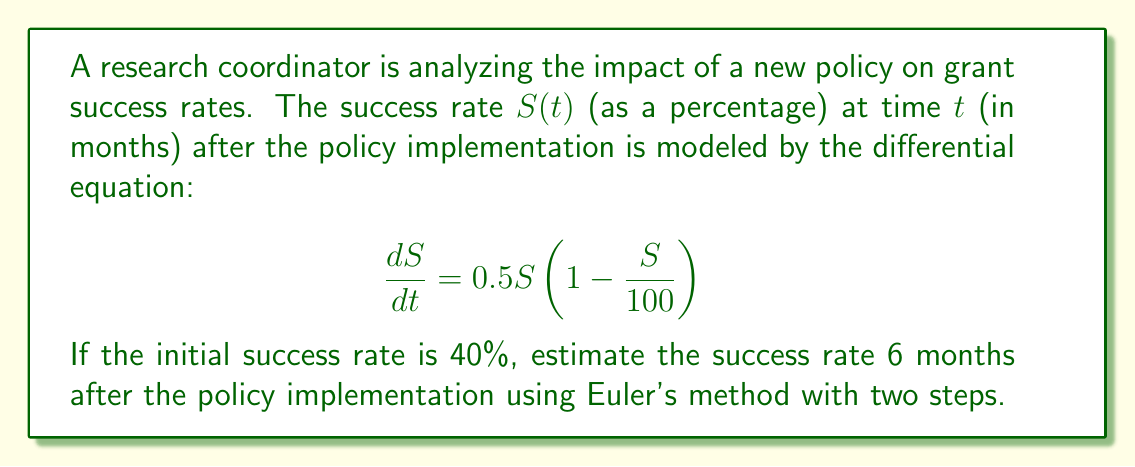Can you answer this question? To solve this problem using Euler's method with two steps, we'll follow these steps:

1) Euler's method is given by the formula:
   $y_{n+1} = y_n + h \cdot f(t_n, y_n)$
   where $h$ is the step size, and $f(t, y) = \frac{dy}{dt}$

2) In our case, $f(t, S) = 0.5S(1 - \frac{S}{100})$

3) We need to estimate $S(6)$ starting from $S(0) = 40$, using two steps. So, our step size $h = 3$ months.

4) Step 1: From $t = 0$ to $t = 3$
   $S_1 = S_0 + h \cdot f(0, S_0)$
   $S_1 = 40 + 3 \cdot [0.5 \cdot 40 \cdot (1 - \frac{40}{100})]$
   $S_1 = 40 + 3 \cdot [20 \cdot 0.6]$
   $S_1 = 40 + 36 = 76$

5) Step 2: From $t = 3$ to $t = 6$
   $S_2 = S_1 + h \cdot f(3, S_1)$
   $S_2 = 76 + 3 \cdot [0.5 \cdot 76 \cdot (1 - \frac{76}{100})]$
   $S_2 = 76 + 3 \cdot [38 \cdot 0.24]$
   $S_2 = 76 + 27.36 = 103.36$

6) Therefore, the estimated success rate after 6 months is approximately 103.36%.
Answer: 103.36% 